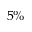Convert formula to latex. <formula><loc_0><loc_0><loc_500><loc_500>5 \%</formula> 